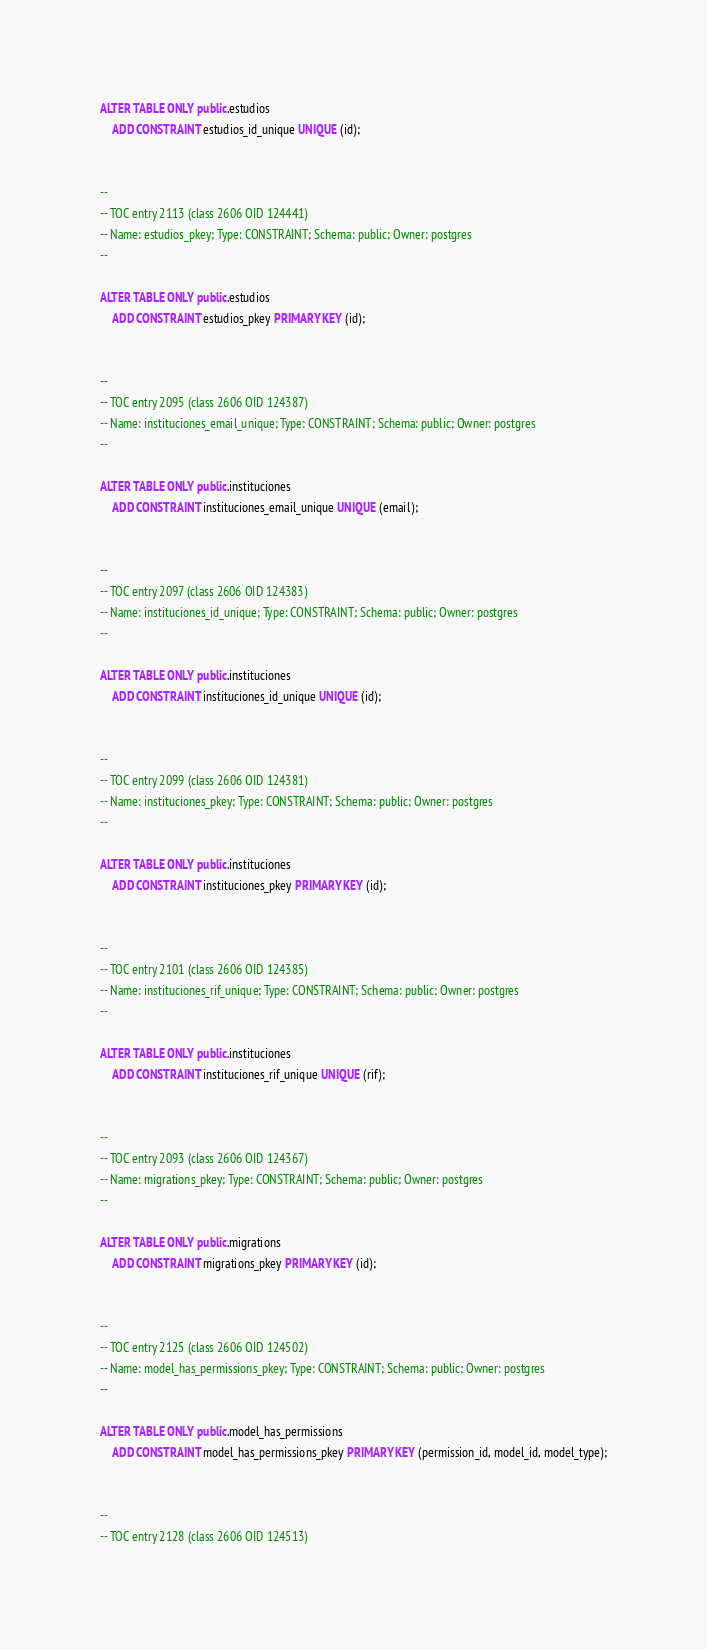<code> <loc_0><loc_0><loc_500><loc_500><_SQL_>
ALTER TABLE ONLY public.estudios
    ADD CONSTRAINT estudios_id_unique UNIQUE (id);


--
-- TOC entry 2113 (class 2606 OID 124441)
-- Name: estudios_pkey; Type: CONSTRAINT; Schema: public; Owner: postgres
--

ALTER TABLE ONLY public.estudios
    ADD CONSTRAINT estudios_pkey PRIMARY KEY (id);


--
-- TOC entry 2095 (class 2606 OID 124387)
-- Name: instituciones_email_unique; Type: CONSTRAINT; Schema: public; Owner: postgres
--

ALTER TABLE ONLY public.instituciones
    ADD CONSTRAINT instituciones_email_unique UNIQUE (email);


--
-- TOC entry 2097 (class 2606 OID 124383)
-- Name: instituciones_id_unique; Type: CONSTRAINT; Schema: public; Owner: postgres
--

ALTER TABLE ONLY public.instituciones
    ADD CONSTRAINT instituciones_id_unique UNIQUE (id);


--
-- TOC entry 2099 (class 2606 OID 124381)
-- Name: instituciones_pkey; Type: CONSTRAINT; Schema: public; Owner: postgres
--

ALTER TABLE ONLY public.instituciones
    ADD CONSTRAINT instituciones_pkey PRIMARY KEY (id);


--
-- TOC entry 2101 (class 2606 OID 124385)
-- Name: instituciones_rif_unique; Type: CONSTRAINT; Schema: public; Owner: postgres
--

ALTER TABLE ONLY public.instituciones
    ADD CONSTRAINT instituciones_rif_unique UNIQUE (rif);


--
-- TOC entry 2093 (class 2606 OID 124367)
-- Name: migrations_pkey; Type: CONSTRAINT; Schema: public; Owner: postgres
--

ALTER TABLE ONLY public.migrations
    ADD CONSTRAINT migrations_pkey PRIMARY KEY (id);


--
-- TOC entry 2125 (class 2606 OID 124502)
-- Name: model_has_permissions_pkey; Type: CONSTRAINT; Schema: public; Owner: postgres
--

ALTER TABLE ONLY public.model_has_permissions
    ADD CONSTRAINT model_has_permissions_pkey PRIMARY KEY (permission_id, model_id, model_type);


--
-- TOC entry 2128 (class 2606 OID 124513)</code> 